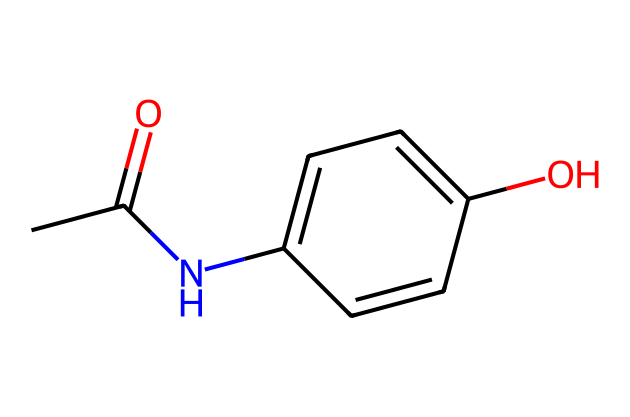What is the chemical name of the structure? The SMILES representation corresponds to a compound that can be identified as acetaminophen, which is a widely known over-the-counter pain reliever.
Answer: acetaminophen How many carbon atoms are present in the chemical? By analyzing the SMILES structure, we count 8 carbon atoms represented in the chemical formula.
Answer: 8 What functional groups are present in this chemical? The structure features an amide group (indicated by NC) and a hydroxyl group (indicated by O), which are essential for its chemical reactivity and biological activity.
Answer: amide and hydroxyl Does this chemical contain any nitrogen atoms? A careful look at the SMILES reveals that there is one nitrogen atom present in the amide functional group.
Answer: yes What type of bonding primarily connects the carbon and oxygen atoms in this compound? In the structure, the carbon and oxygen are primarily connected by double bonds (as in the carbonyl group C=O of the amide and hydroxyl groups).
Answer: double bond Can this chemical be classified as a non-opioid analgesic? Given its classification and therapeutic use, acetaminophen is indeed regarded as a non-opioid analgesic, used for pain relief without the addictive properties associated with opioids.
Answer: yes 